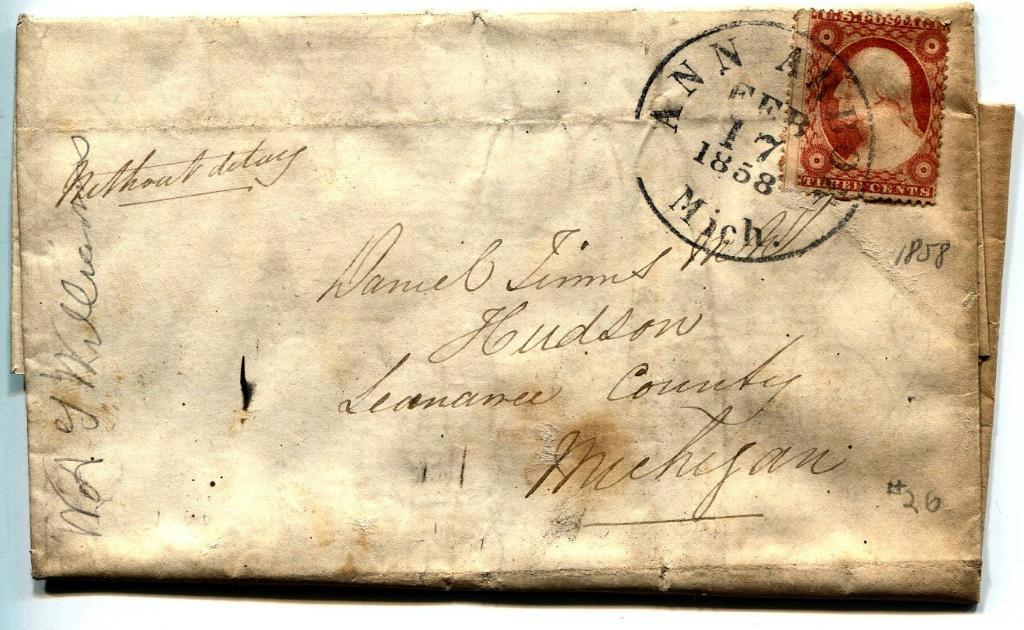Provide a one-sentence caption for the provided image. a very antique letter post marked Feb 17 1858 in Ann Arbor Mich. 